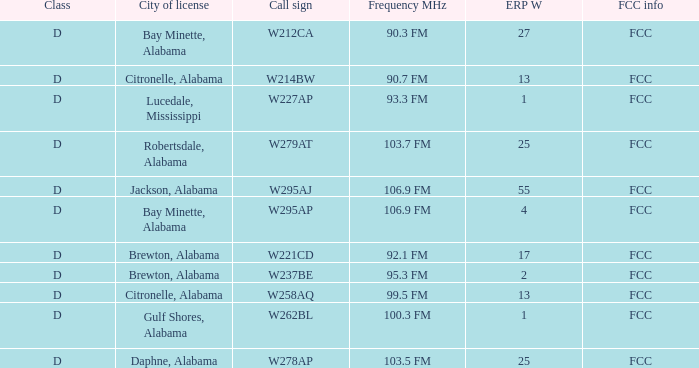Name the FCC info for call sign of w279at FCC. 